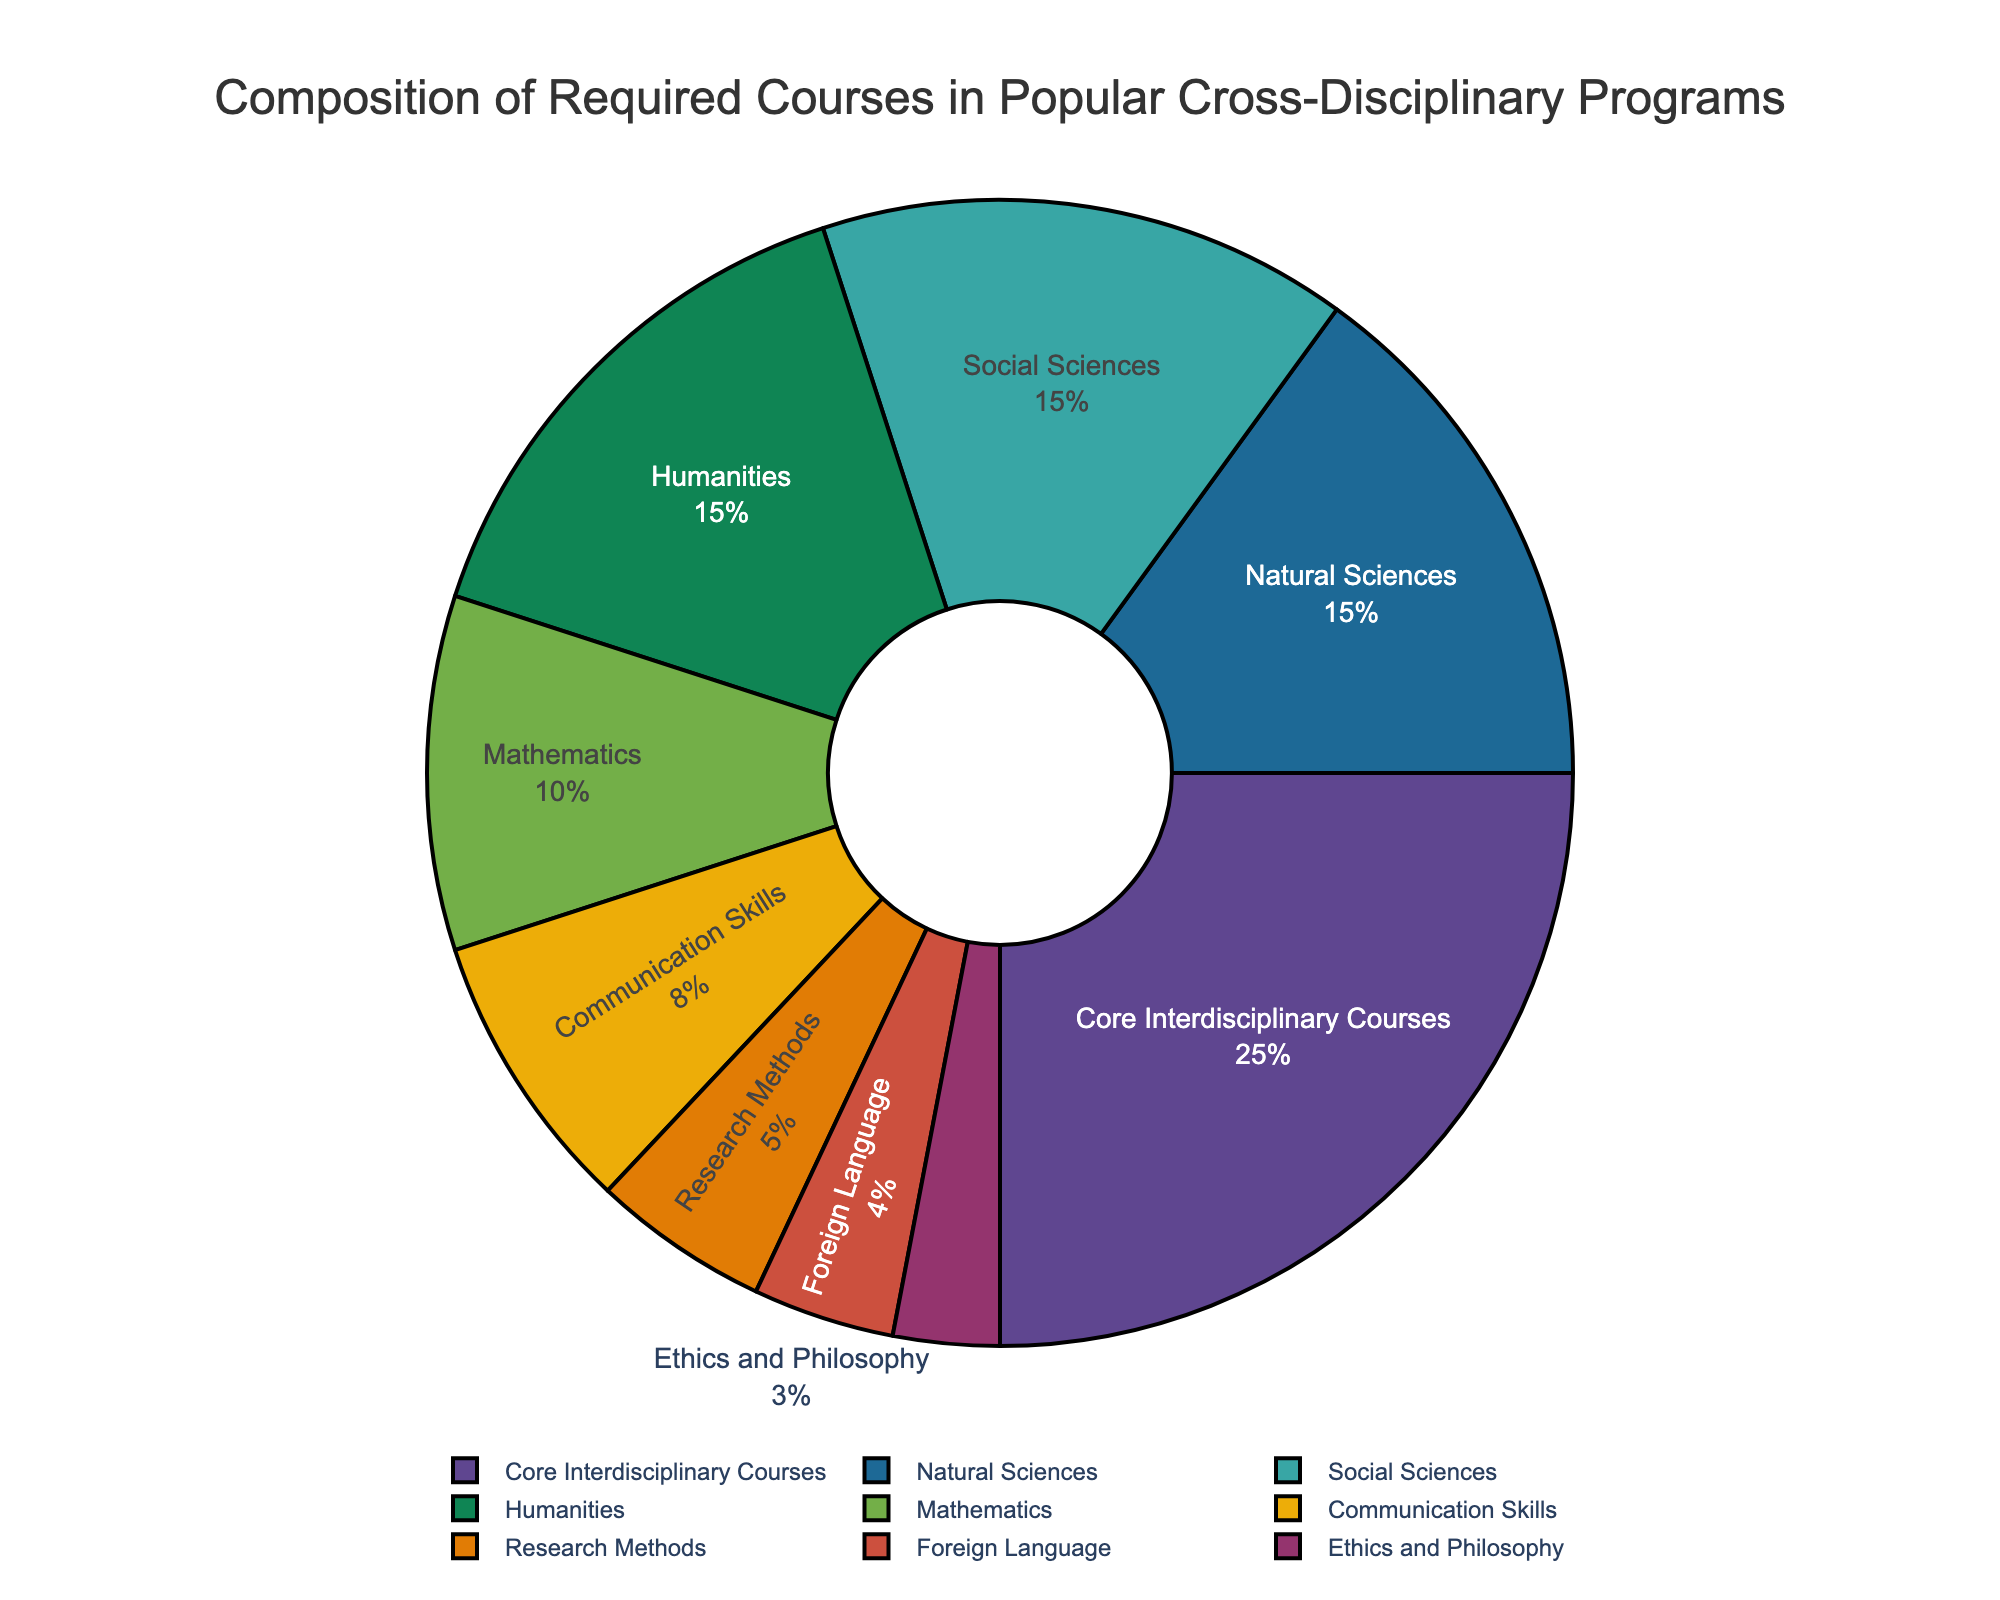Which category has the highest percentage of required courses? The figure shows the "Core Interdisciplinary Courses" segment taking up the largest portion of the pie chart. This segment should have the highest percentage according to the visual representation.
Answer: Core Interdisciplinary Courses Which section has a smaller percentage, Research Methods or Foreign Language? By looking at the pie chart, it is clear that the segment for Research Methods is smaller than the Foreign Language segment. This indicates that the percentage for Research Methods is less.
Answer: Research Methods What is the total percentage of courses dedicated to the Natural Sciences and Social Sciences combined? The percentages for Natural Sciences and Social Sciences are given as 15% each. Adding them gives the total: 15% + 15% = 30%.
Answer: 30% Compare the percentages of Humanities and Mathematics courses. Which one has more? The Humanities section and Mathematics section can be compared visually, and the Humanities section appears larger. Hence, its percentage is higher than Mathematics.
Answer: Humanities What is the difference in the percentage of courses between Communication Skills and Mathematics? The percentages for Communication Skills and Mathematics are 8% and 10%, respectively. The difference can be calculated as 10% - 8% = 2%.
Answer: 2% If you totaled the percentages of Ethics and Philosophy, Foreign Language, and Research Methods, what would it be? Add the percentages of Ethics and Philosophy (3%), Foreign Language (4%), and Research Methods (5%): 3% + 4% + 5% = 12%.
Answer: 12% Which sections take up an equal percentage in the pie chart? By examining the chart, Natural Sciences, Social Sciences, and Humanities all appear to occupy equal portions of the pie. Each has a percentage of 15%.
Answer: Natural Sciences, Social Sciences, Humanities Is the percentage of Core Interdisciplinary Courses more than double that of Communication Skills? The percentage of Core Interdisciplinary Courses is 25%, while Communication Skills is 8%. Doubling 8% gives 16%, and 25% is indeed more than 16%.
Answer: Yes Which section has the smallest percentage of required courses? The smallest segment in the pie chart corresponds to Ethics and Philosophy, indicating it has the smallest percentage.
Answer: Ethics and Philosophy 